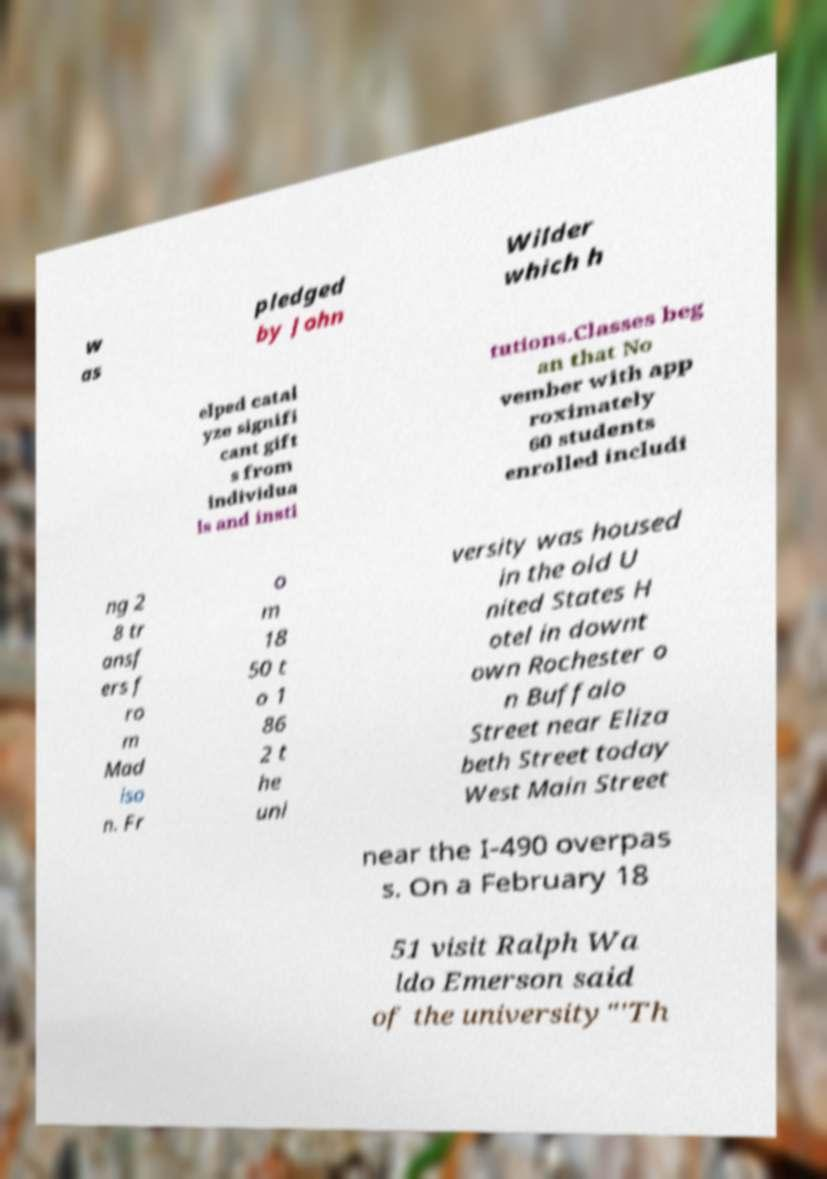Could you assist in decoding the text presented in this image and type it out clearly? w as pledged by John Wilder which h elped catal yze signifi cant gift s from individua ls and insti tutions.Classes beg an that No vember with app roximately 60 students enrolled includi ng 2 8 tr ansf ers f ro m Mad iso n. Fr o m 18 50 t o 1 86 2 t he uni versity was housed in the old U nited States H otel in downt own Rochester o n Buffalo Street near Eliza beth Street today West Main Street near the I-490 overpas s. On a February 18 51 visit Ralph Wa ldo Emerson said of the university"'Th 